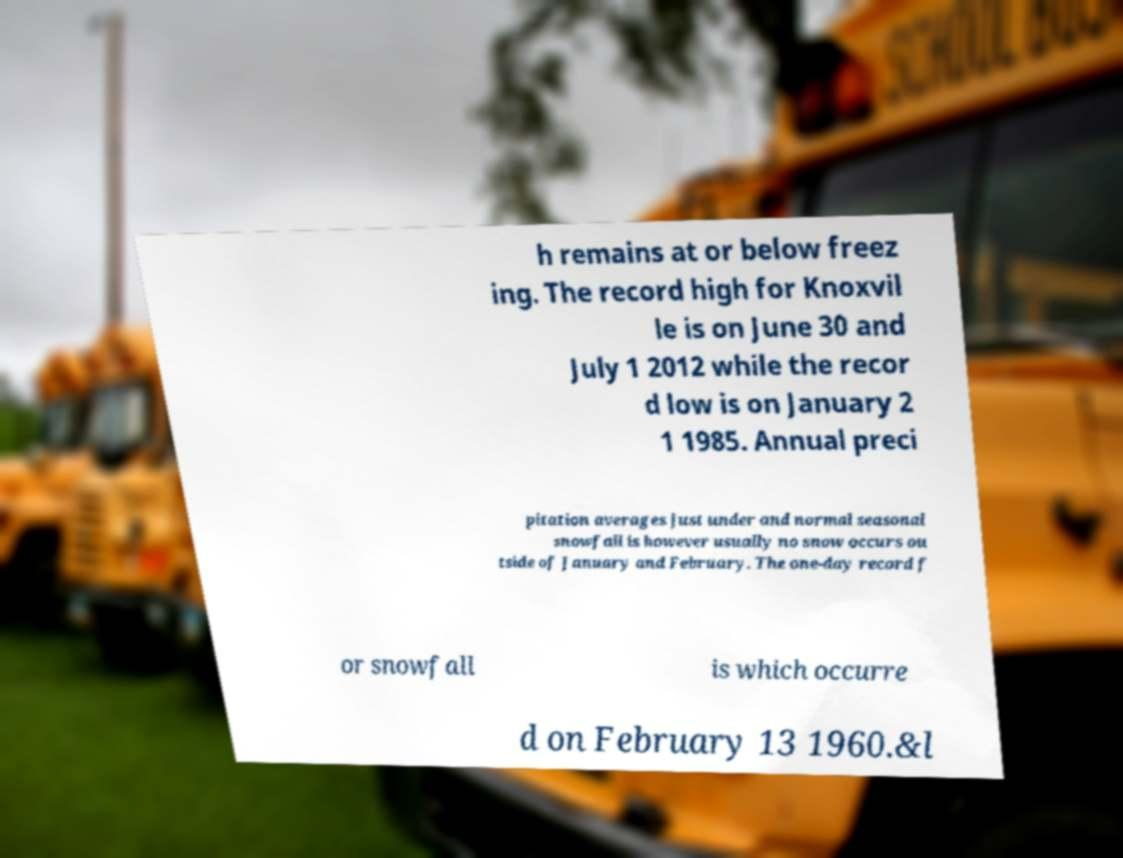I need the written content from this picture converted into text. Can you do that? h remains at or below freez ing. The record high for Knoxvil le is on June 30 and July 1 2012 while the recor d low is on January 2 1 1985. Annual preci pitation averages just under and normal seasonal snowfall is however usually no snow occurs ou tside of January and February. The one-day record f or snowfall is which occurre d on February 13 1960.&l 